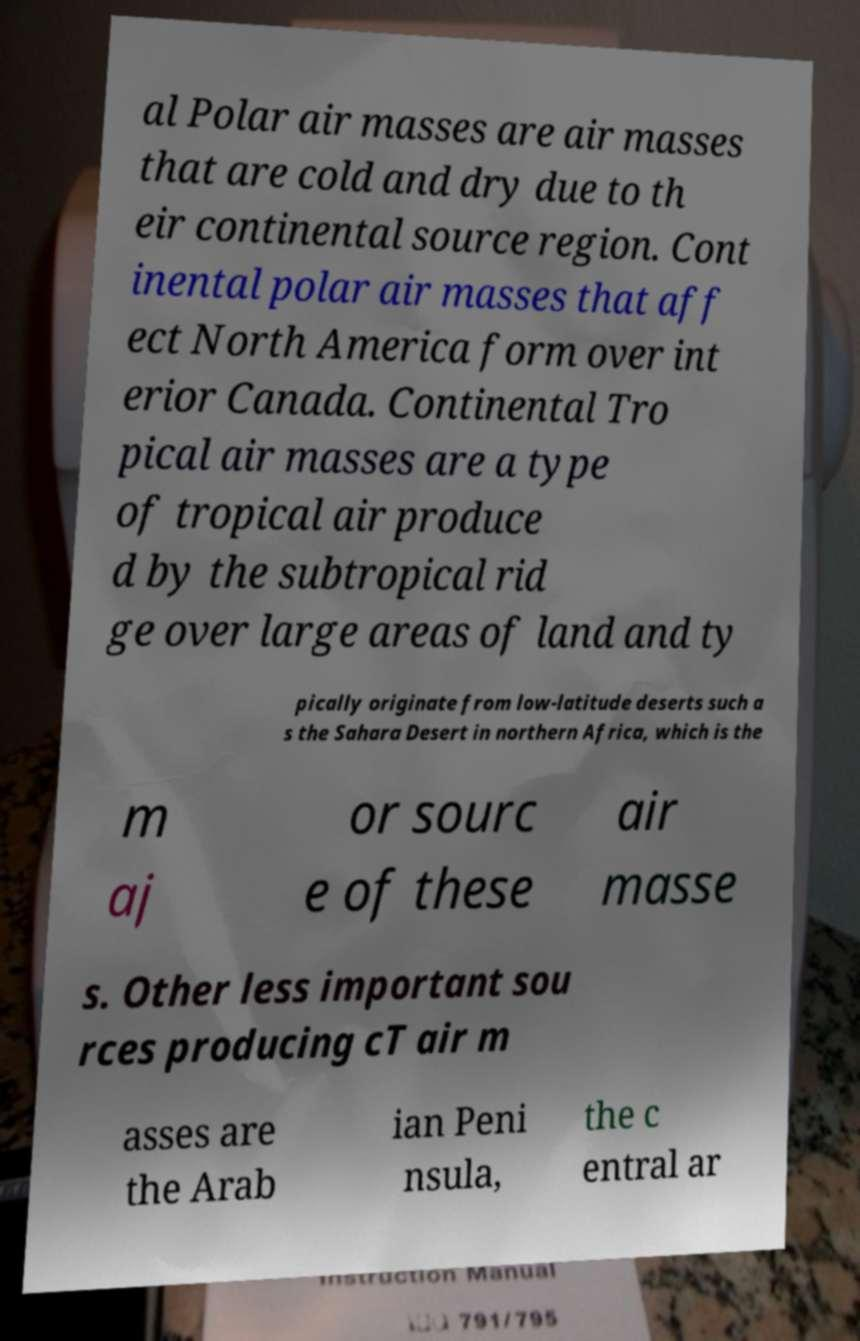Could you extract and type out the text from this image? al Polar air masses are air masses that are cold and dry due to th eir continental source region. Cont inental polar air masses that aff ect North America form over int erior Canada. Continental Tro pical air masses are a type of tropical air produce d by the subtropical rid ge over large areas of land and ty pically originate from low-latitude deserts such a s the Sahara Desert in northern Africa, which is the m aj or sourc e of these air masse s. Other less important sou rces producing cT air m asses are the Arab ian Peni nsula, the c entral ar 